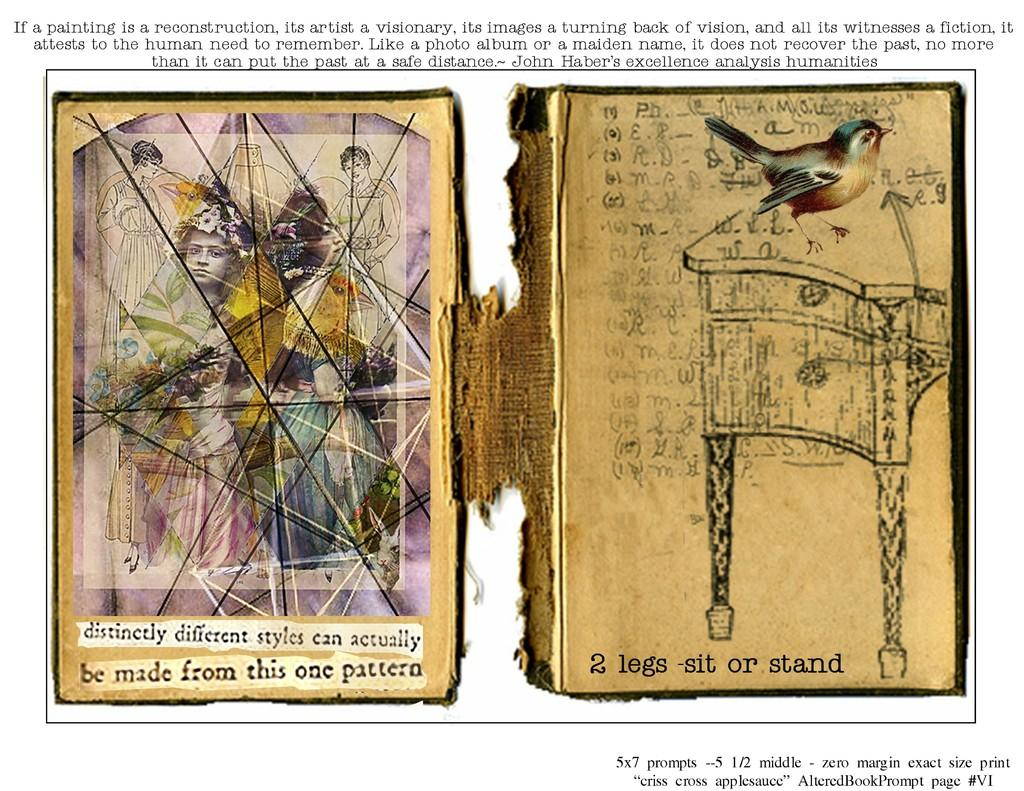How many posters are in the image? There are two posters in the image. What can be seen on the posters? There are pictures on the posters. Is there any text visible in the image? Yes, there is text visible in the image. Where is the straw located in the image? There is no straw present in the image. What type of cup is depicted on the posters? The posters do not depict any cups; they have pictures and text. 